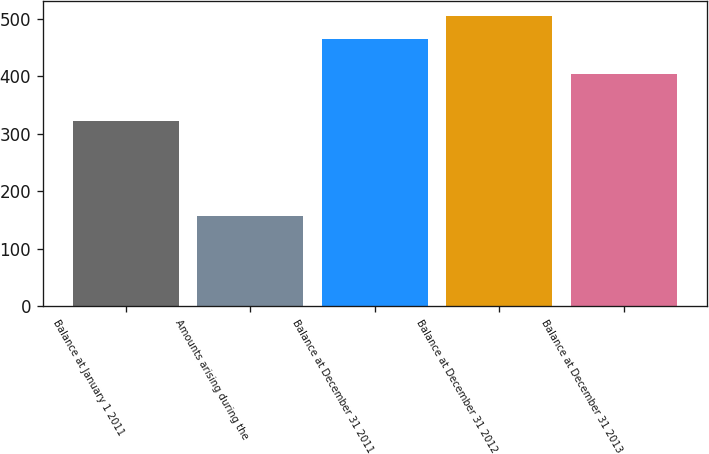<chart> <loc_0><loc_0><loc_500><loc_500><bar_chart><fcel>Balance at January 1 2011<fcel>Amounts arising during the<fcel>Balance at December 31 2011<fcel>Balance at December 31 2012<fcel>Balance at December 31 2013<nl><fcel>323<fcel>157<fcel>465<fcel>506<fcel>405<nl></chart> 